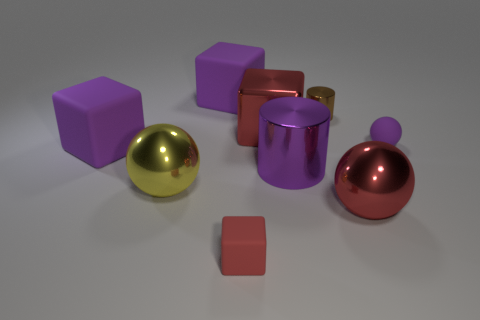How many purple blocks must be subtracted to get 1 purple blocks? 1 Subtract all gray cylinders. How many purple blocks are left? 2 Subtract all shiny blocks. How many blocks are left? 3 Subtract 1 spheres. How many spheres are left? 2 Add 1 brown metal cylinders. How many objects exist? 10 Subtract all green blocks. Subtract all purple cylinders. How many blocks are left? 4 Subtract all spheres. How many objects are left? 6 Subtract 0 yellow cylinders. How many objects are left? 9 Subtract all small cylinders. Subtract all rubber blocks. How many objects are left? 5 Add 4 red shiny things. How many red shiny things are left? 6 